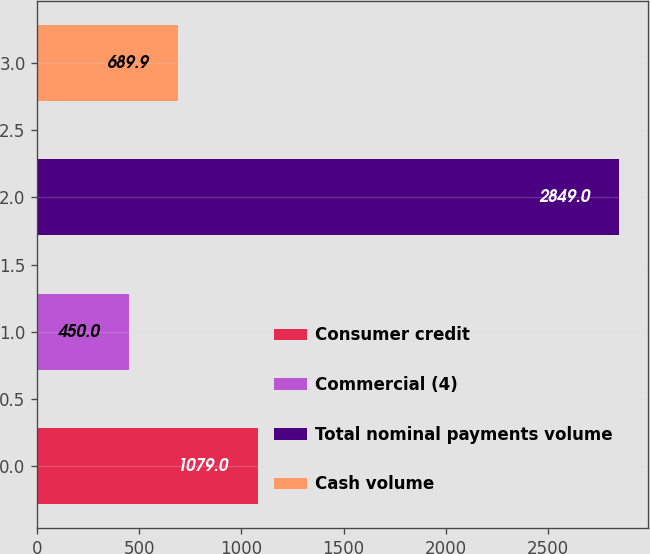<chart> <loc_0><loc_0><loc_500><loc_500><bar_chart><fcel>Consumer credit<fcel>Commercial (4)<fcel>Total nominal payments volume<fcel>Cash volume<nl><fcel>1079<fcel>450<fcel>2849<fcel>689.9<nl></chart> 